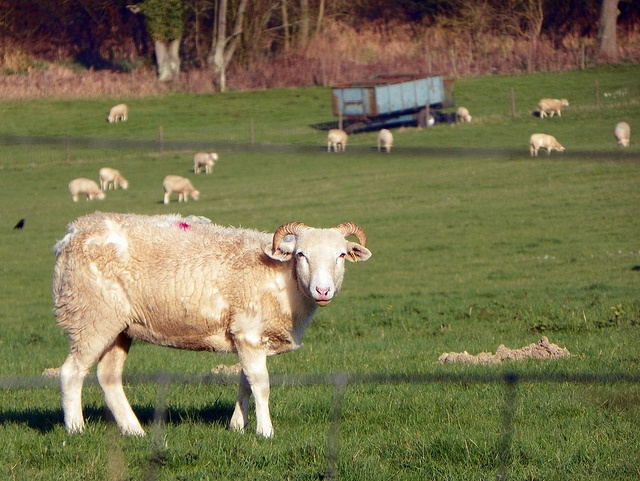Describe the objects in this image and their specific colors. I can see sheep in black, tan, and beige tones, truck in black, darkgray, and gray tones, sheep in black and tan tones, sheep in black, tan, and olive tones, and sheep in black, tan, and gray tones in this image. 